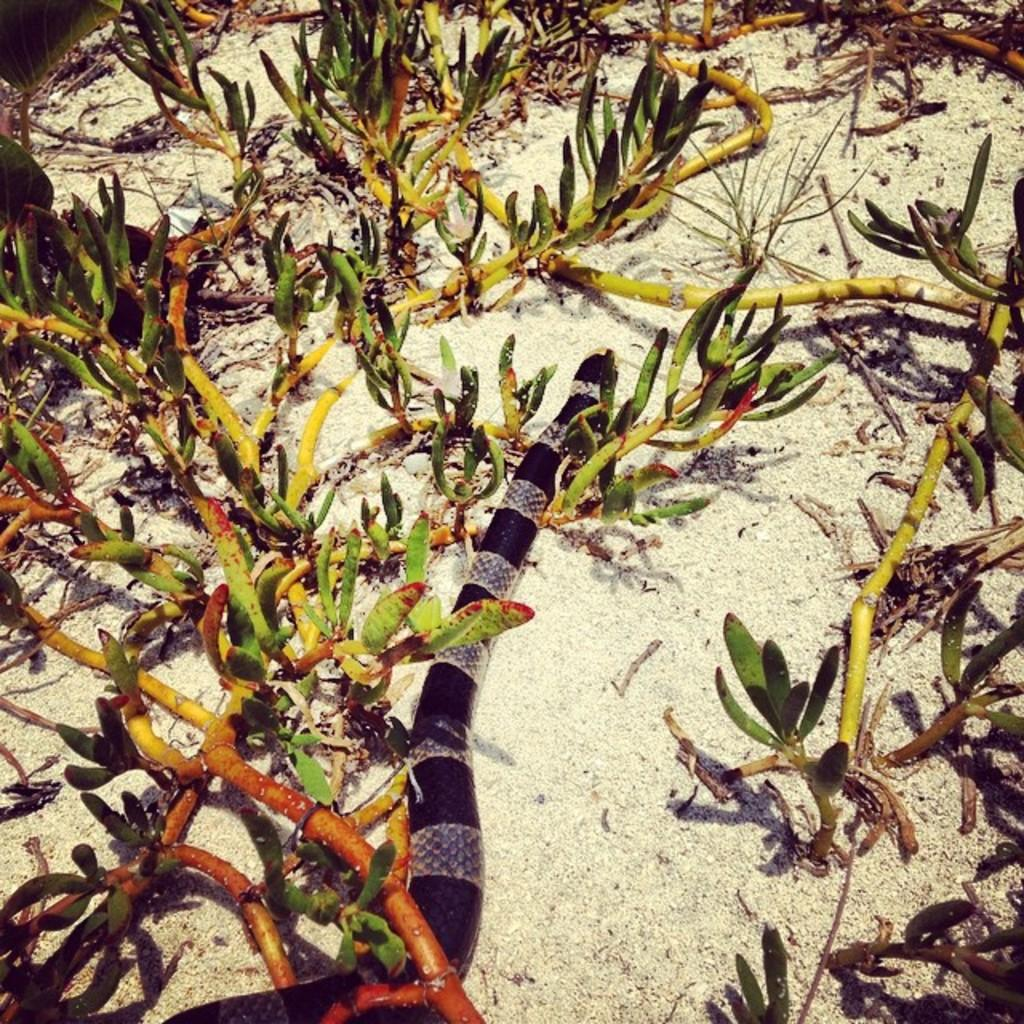Where was the picture taken? The picture was clicked outside. What can be seen on the ground in the image? There is a snake on the ground in the image. What type of vegetation is visible in the image? There are branches, stems, and leaves visible in the image. Can you describe any other objects present in the image? There are other objects present in the image, but their specific details are not mentioned in the provided facts. What type of impulse can be seen affecting the snake in the image? There is no mention of any impulse affecting the snake in the image. Can you read the note that the snake is holding in the image? There is no note present in the image, as it features a snake on the ground and vegetation. 